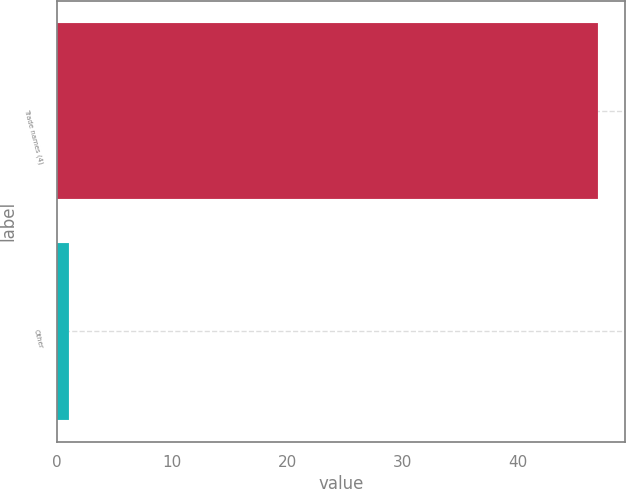<chart> <loc_0><loc_0><loc_500><loc_500><bar_chart><fcel>Trade names (4)<fcel>Other<nl><fcel>47<fcel>1<nl></chart> 